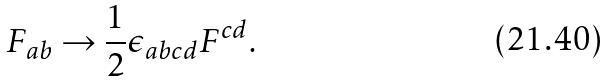Convert formula to latex. <formula><loc_0><loc_0><loc_500><loc_500>F _ { a b } \rightarrow { \frac { 1 } { 2 } } \epsilon _ { a b c d } F ^ { c d } .</formula> 